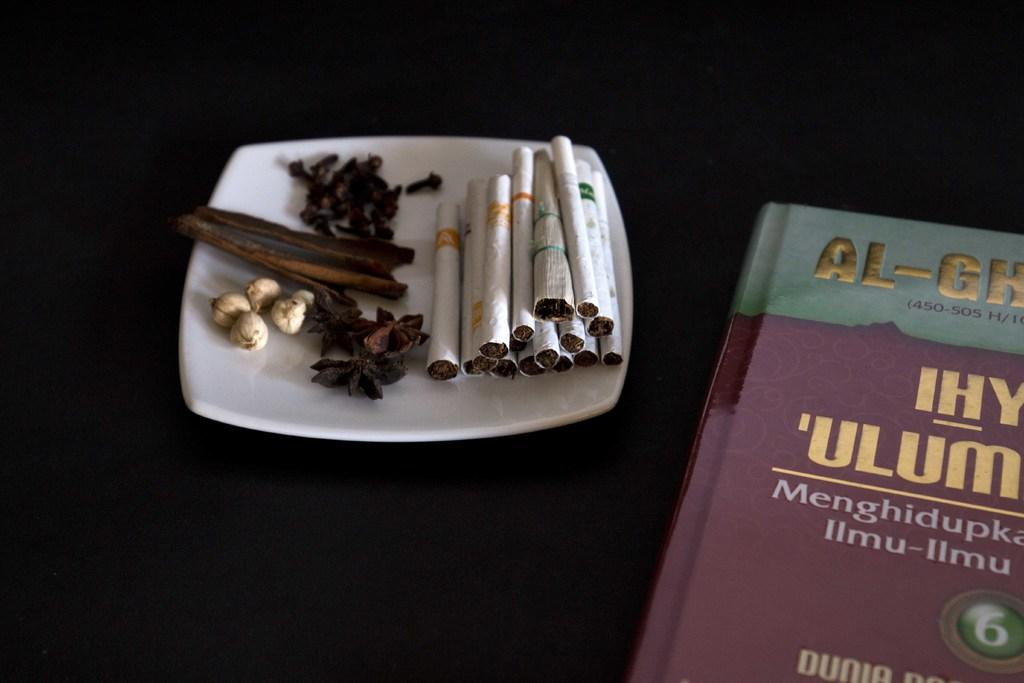<image>
Relay a brief, clear account of the picture shown. A book with Al in gold letters sits next to clove cigarettes. 